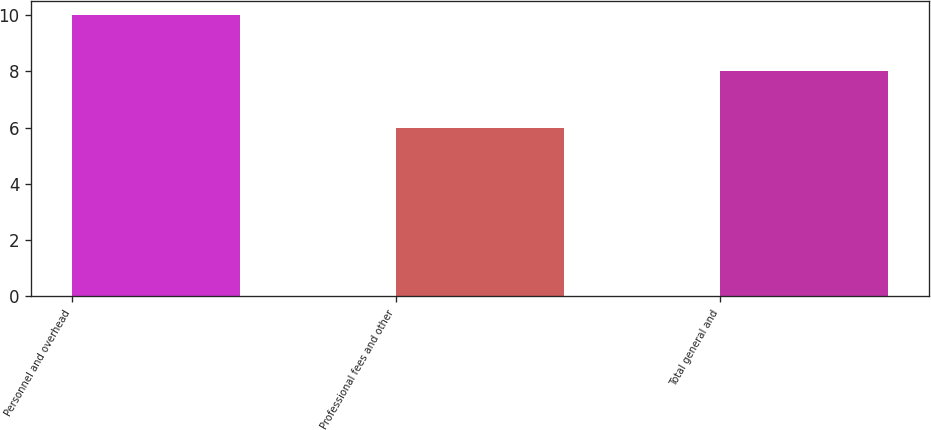Convert chart. <chart><loc_0><loc_0><loc_500><loc_500><bar_chart><fcel>Personnel and overhead<fcel>Professional fees and other<fcel>Total general and<nl><fcel>10<fcel>6<fcel>8<nl></chart> 